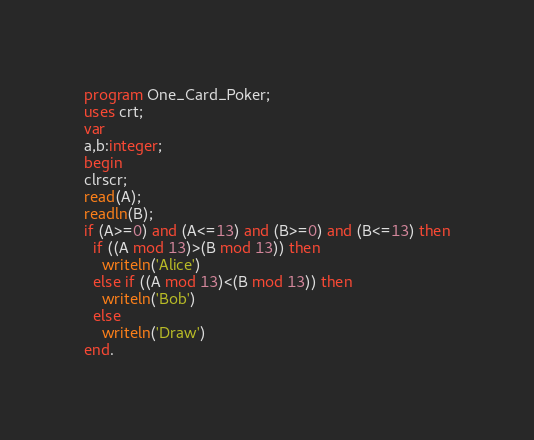<code> <loc_0><loc_0><loc_500><loc_500><_Pascal_>program One_Card_Poker;
uses crt;
var
a,b:integer;
begin
clrscr;
read(A);
readln(B);
if (A>=0) and (A<=13) and (B>=0) and (B<=13) then
  if ((A mod 13)>(B mod 13)) then
    writeln('Alice')
  else if ((A mod 13)<(B mod 13)) then
    writeln('Bob')
  else
    writeln('Draw')
end.</code> 